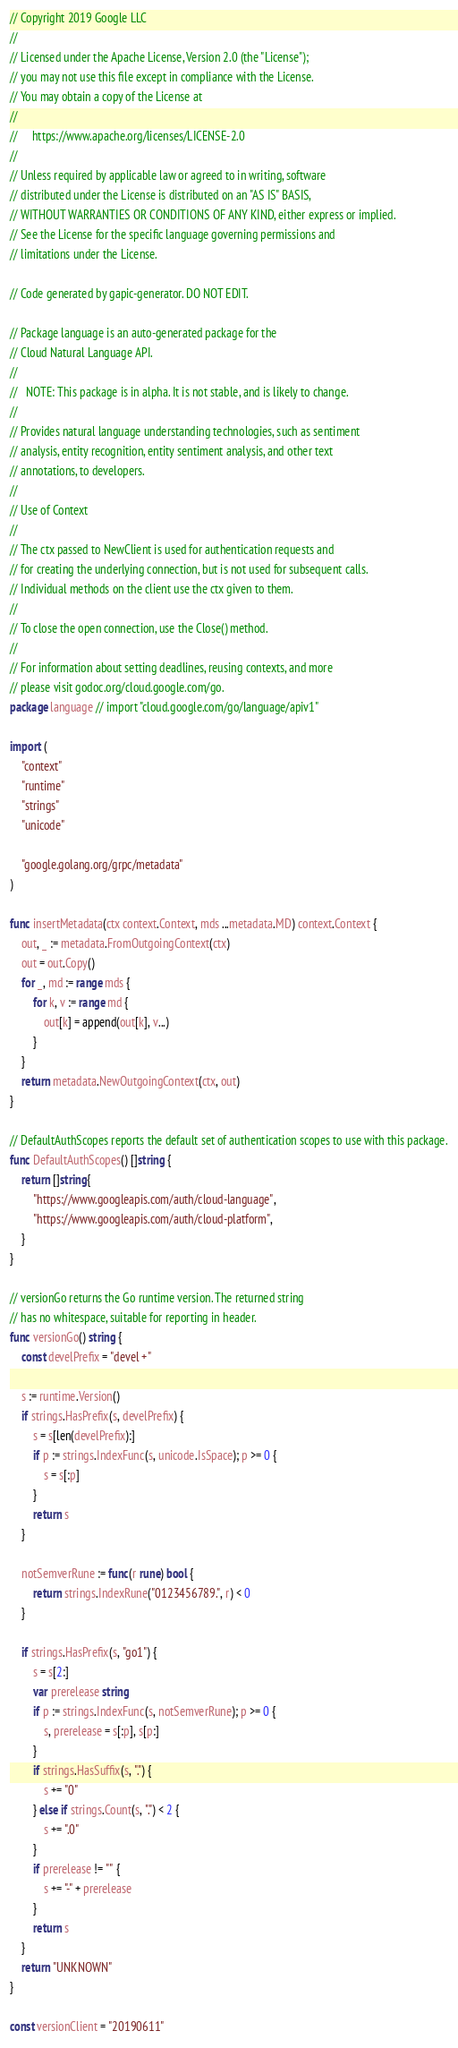Convert code to text. <code><loc_0><loc_0><loc_500><loc_500><_Go_>// Copyright 2019 Google LLC
//
// Licensed under the Apache License, Version 2.0 (the "License");
// you may not use this file except in compliance with the License.
// You may obtain a copy of the License at
//
//     https://www.apache.org/licenses/LICENSE-2.0
//
// Unless required by applicable law or agreed to in writing, software
// distributed under the License is distributed on an "AS IS" BASIS,
// WITHOUT WARRANTIES OR CONDITIONS OF ANY KIND, either express or implied.
// See the License for the specific language governing permissions and
// limitations under the License.

// Code generated by gapic-generator. DO NOT EDIT.

// Package language is an auto-generated package for the
// Cloud Natural Language API.
//
//   NOTE: This package is in alpha. It is not stable, and is likely to change.
//
// Provides natural language understanding technologies, such as sentiment
// analysis, entity recognition, entity sentiment analysis, and other text
// annotations, to developers.
//
// Use of Context
//
// The ctx passed to NewClient is used for authentication requests and
// for creating the underlying connection, but is not used for subsequent calls.
// Individual methods on the client use the ctx given to them.
//
// To close the open connection, use the Close() method.
//
// For information about setting deadlines, reusing contexts, and more
// please visit godoc.org/cloud.google.com/go.
package language // import "cloud.google.com/go/language/apiv1"

import (
	"context"
	"runtime"
	"strings"
	"unicode"

	"google.golang.org/grpc/metadata"
)

func insertMetadata(ctx context.Context, mds ...metadata.MD) context.Context {
	out, _ := metadata.FromOutgoingContext(ctx)
	out = out.Copy()
	for _, md := range mds {
		for k, v := range md {
			out[k] = append(out[k], v...)
		}
	}
	return metadata.NewOutgoingContext(ctx, out)
}

// DefaultAuthScopes reports the default set of authentication scopes to use with this package.
func DefaultAuthScopes() []string {
	return []string{
		"https://www.googleapis.com/auth/cloud-language",
		"https://www.googleapis.com/auth/cloud-platform",
	}
}

// versionGo returns the Go runtime version. The returned string
// has no whitespace, suitable for reporting in header.
func versionGo() string {
	const develPrefix = "devel +"

	s := runtime.Version()
	if strings.HasPrefix(s, develPrefix) {
		s = s[len(develPrefix):]
		if p := strings.IndexFunc(s, unicode.IsSpace); p >= 0 {
			s = s[:p]
		}
		return s
	}

	notSemverRune := func(r rune) bool {
		return strings.IndexRune("0123456789.", r) < 0
	}

	if strings.HasPrefix(s, "go1") {
		s = s[2:]
		var prerelease string
		if p := strings.IndexFunc(s, notSemverRune); p >= 0 {
			s, prerelease = s[:p], s[p:]
		}
		if strings.HasSuffix(s, ".") {
			s += "0"
		} else if strings.Count(s, ".") < 2 {
			s += ".0"
		}
		if prerelease != "" {
			s += "-" + prerelease
		}
		return s
	}
	return "UNKNOWN"
}

const versionClient = "20190611"
</code> 